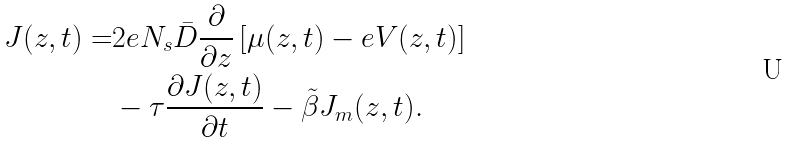Convert formula to latex. <formula><loc_0><loc_0><loc_500><loc_500>J ( z , t ) = & 2 e N _ { s } \bar { D } \frac { \partial } { \partial { z } } \left [ \mu ( z , t ) - e V ( z , t ) \right ] \\ & - \tau \frac { \partial { J ( z , t ) } } { \partial { t } } - \tilde { \beta } J _ { m } ( z , t ) .</formula> 